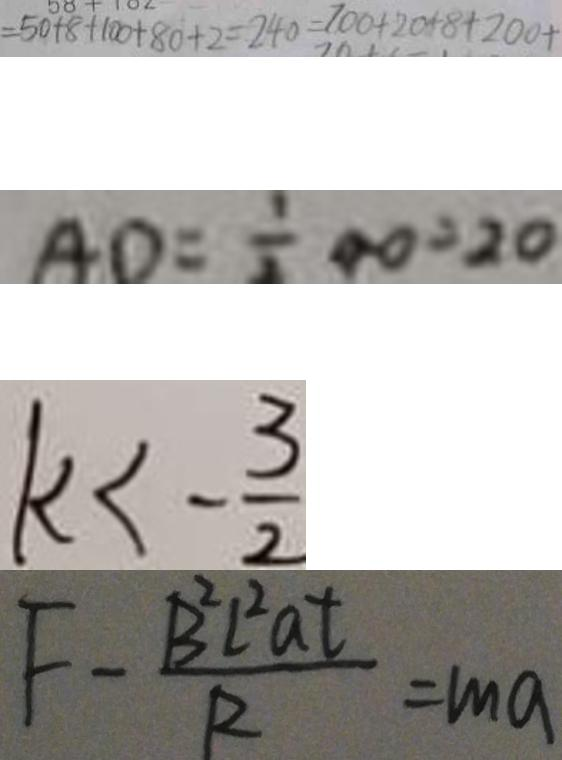Convert formula to latex. <formula><loc_0><loc_0><loc_500><loc_500>= 5 0 + 8 + 1 0 0 + 8 0 + 2 = 2 4 0 = 7 0 0 + 2 0 + 8 + 2 0 0 + 
 A D = \frac { 1 } { 2 } A O = 2 0 
 k < - \frac { 3 } { 2 } 
 F - \frac { B ^ { 2 } l ^ { 2 } a t } { R } = m a</formula> 